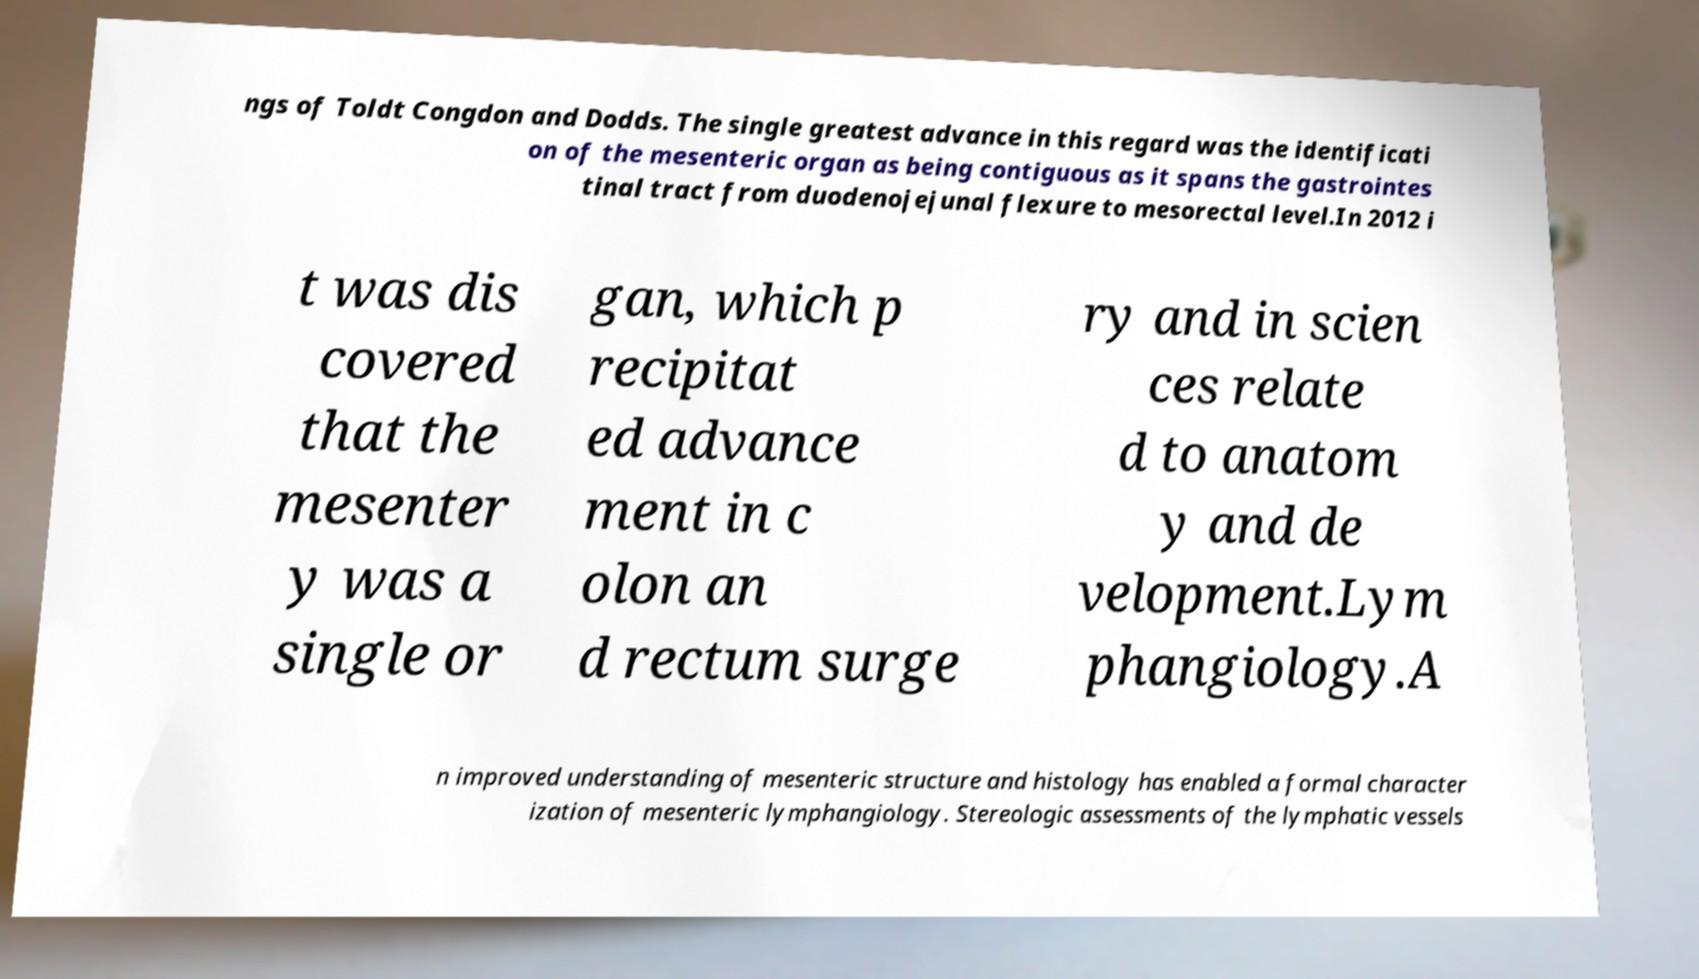Could you extract and type out the text from this image? ngs of Toldt Congdon and Dodds. The single greatest advance in this regard was the identificati on of the mesenteric organ as being contiguous as it spans the gastrointes tinal tract from duodenojejunal flexure to mesorectal level.In 2012 i t was dis covered that the mesenter y was a single or gan, which p recipitat ed advance ment in c olon an d rectum surge ry and in scien ces relate d to anatom y and de velopment.Lym phangiology.A n improved understanding of mesenteric structure and histology has enabled a formal character ization of mesenteric lymphangiology. Stereologic assessments of the lymphatic vessels 